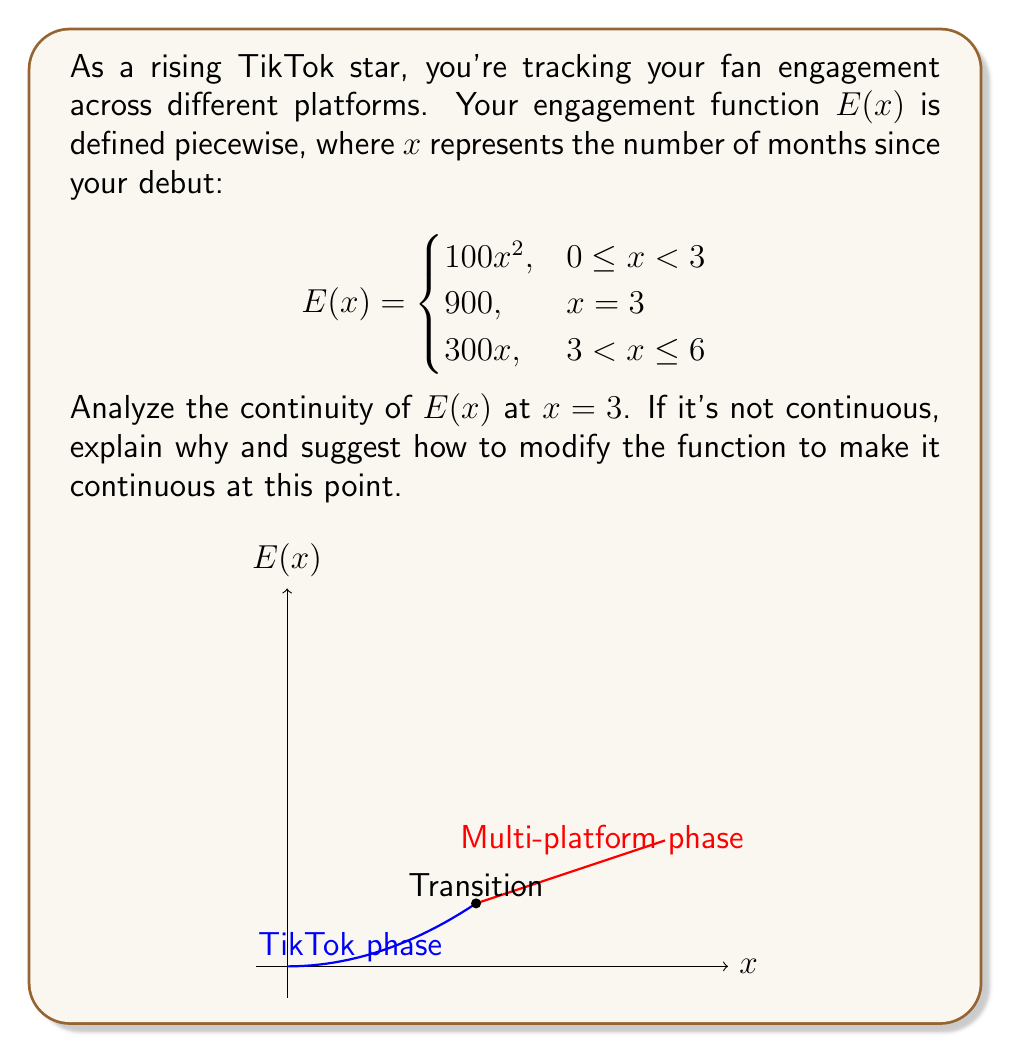What is the answer to this math problem? To analyze the continuity of $E(x)$ at $x = 3$, we need to check three conditions:

1) $E(3)$ exists
2) $\lim_{x \to 3^-} E(x)$ exists
3) $\lim_{x \to 3^+} E(x)$ exists
4) All three values are equal

Step 1: $E(3)$ exists and equals 900.

Step 2: $\lim_{x \to 3^-} E(x) = \lim_{x \to 3^-} 100x^2 = 100(3)^2 = 900$

Step 3: $\lim_{x \to 3^+} E(x) = \lim_{x \to 3^+} 300x = 300(3) = 900$

Step 4: Comparing the values:
$E(3) = 900$
$\lim_{x \to 3^-} E(x) = 900$
$\lim_{x \to 3^+} E(x) = 900$

All three values are equal to 900, therefore $E(x)$ is continuous at $x = 3$.

The function accurately represents a smooth transition from your TikTok-focused phase to a multi-platform strategy, maintaining continuity in fan engagement.
Answer: $E(x)$ is continuous at $x = 3$. 